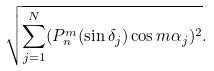Convert formula to latex. <formula><loc_0><loc_0><loc_500><loc_500>\sqrt { \sum _ { j = 1 } ^ { N } ( P _ { n } ^ { m } ( \sin \delta _ { j } ) \cos m \alpha _ { j } ) ^ { 2 } } .</formula> 